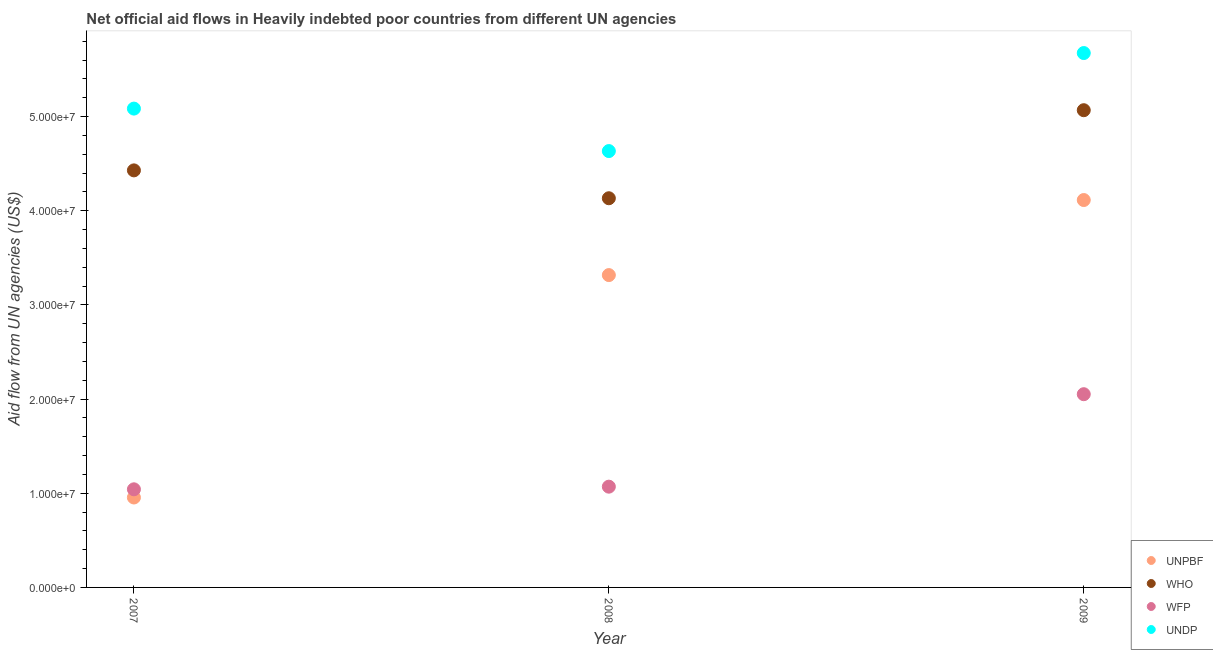What is the amount of aid given by undp in 2009?
Offer a very short reply. 5.68e+07. Across all years, what is the maximum amount of aid given by undp?
Provide a succinct answer. 5.68e+07. Across all years, what is the minimum amount of aid given by who?
Offer a very short reply. 4.13e+07. What is the total amount of aid given by who in the graph?
Provide a short and direct response. 1.36e+08. What is the difference between the amount of aid given by who in 2007 and that in 2008?
Your response must be concise. 2.96e+06. What is the difference between the amount of aid given by who in 2008 and the amount of aid given by unpbf in 2009?
Your response must be concise. 1.90e+05. What is the average amount of aid given by wfp per year?
Your answer should be very brief. 1.39e+07. In the year 2007, what is the difference between the amount of aid given by undp and amount of aid given by wfp?
Your answer should be very brief. 4.04e+07. In how many years, is the amount of aid given by who greater than 28000000 US$?
Your response must be concise. 3. What is the ratio of the amount of aid given by wfp in 2008 to that in 2009?
Offer a terse response. 0.52. What is the difference between the highest and the second highest amount of aid given by unpbf?
Provide a succinct answer. 7.97e+06. What is the difference between the highest and the lowest amount of aid given by unpbf?
Your answer should be very brief. 3.16e+07. Is the sum of the amount of aid given by who in 2007 and 2008 greater than the maximum amount of aid given by unpbf across all years?
Ensure brevity in your answer.  Yes. Does the amount of aid given by who monotonically increase over the years?
Keep it short and to the point. No. How many years are there in the graph?
Offer a terse response. 3. What is the difference between two consecutive major ticks on the Y-axis?
Your answer should be compact. 1.00e+07. Does the graph contain grids?
Ensure brevity in your answer.  No. How many legend labels are there?
Provide a succinct answer. 4. How are the legend labels stacked?
Make the answer very short. Vertical. What is the title of the graph?
Your answer should be very brief. Net official aid flows in Heavily indebted poor countries from different UN agencies. What is the label or title of the X-axis?
Offer a terse response. Year. What is the label or title of the Y-axis?
Your response must be concise. Aid flow from UN agencies (US$). What is the Aid flow from UN agencies (US$) in UNPBF in 2007?
Provide a short and direct response. 9.55e+06. What is the Aid flow from UN agencies (US$) of WHO in 2007?
Your response must be concise. 4.43e+07. What is the Aid flow from UN agencies (US$) of WFP in 2007?
Make the answer very short. 1.04e+07. What is the Aid flow from UN agencies (US$) of UNDP in 2007?
Your answer should be compact. 5.08e+07. What is the Aid flow from UN agencies (US$) of UNPBF in 2008?
Ensure brevity in your answer.  3.32e+07. What is the Aid flow from UN agencies (US$) in WHO in 2008?
Your response must be concise. 4.13e+07. What is the Aid flow from UN agencies (US$) in WFP in 2008?
Keep it short and to the point. 1.07e+07. What is the Aid flow from UN agencies (US$) in UNDP in 2008?
Provide a succinct answer. 4.63e+07. What is the Aid flow from UN agencies (US$) in UNPBF in 2009?
Your response must be concise. 4.11e+07. What is the Aid flow from UN agencies (US$) in WHO in 2009?
Ensure brevity in your answer.  5.07e+07. What is the Aid flow from UN agencies (US$) of WFP in 2009?
Provide a short and direct response. 2.05e+07. What is the Aid flow from UN agencies (US$) of UNDP in 2009?
Provide a succinct answer. 5.68e+07. Across all years, what is the maximum Aid flow from UN agencies (US$) in UNPBF?
Your response must be concise. 4.11e+07. Across all years, what is the maximum Aid flow from UN agencies (US$) in WHO?
Keep it short and to the point. 5.07e+07. Across all years, what is the maximum Aid flow from UN agencies (US$) in WFP?
Give a very brief answer. 2.05e+07. Across all years, what is the maximum Aid flow from UN agencies (US$) of UNDP?
Ensure brevity in your answer.  5.68e+07. Across all years, what is the minimum Aid flow from UN agencies (US$) of UNPBF?
Ensure brevity in your answer.  9.55e+06. Across all years, what is the minimum Aid flow from UN agencies (US$) of WHO?
Your answer should be compact. 4.13e+07. Across all years, what is the minimum Aid flow from UN agencies (US$) of WFP?
Your answer should be compact. 1.04e+07. Across all years, what is the minimum Aid flow from UN agencies (US$) of UNDP?
Keep it short and to the point. 4.63e+07. What is the total Aid flow from UN agencies (US$) in UNPBF in the graph?
Your answer should be very brief. 8.39e+07. What is the total Aid flow from UN agencies (US$) of WHO in the graph?
Make the answer very short. 1.36e+08. What is the total Aid flow from UN agencies (US$) in WFP in the graph?
Make the answer very short. 4.16e+07. What is the total Aid flow from UN agencies (US$) in UNDP in the graph?
Ensure brevity in your answer.  1.54e+08. What is the difference between the Aid flow from UN agencies (US$) of UNPBF in 2007 and that in 2008?
Offer a terse response. -2.36e+07. What is the difference between the Aid flow from UN agencies (US$) of WHO in 2007 and that in 2008?
Provide a succinct answer. 2.96e+06. What is the difference between the Aid flow from UN agencies (US$) in WFP in 2007 and that in 2008?
Keep it short and to the point. -2.80e+05. What is the difference between the Aid flow from UN agencies (US$) of UNDP in 2007 and that in 2008?
Your answer should be very brief. 4.51e+06. What is the difference between the Aid flow from UN agencies (US$) in UNPBF in 2007 and that in 2009?
Offer a terse response. -3.16e+07. What is the difference between the Aid flow from UN agencies (US$) in WHO in 2007 and that in 2009?
Ensure brevity in your answer.  -6.39e+06. What is the difference between the Aid flow from UN agencies (US$) in WFP in 2007 and that in 2009?
Provide a short and direct response. -1.01e+07. What is the difference between the Aid flow from UN agencies (US$) in UNDP in 2007 and that in 2009?
Ensure brevity in your answer.  -5.90e+06. What is the difference between the Aid flow from UN agencies (US$) in UNPBF in 2008 and that in 2009?
Make the answer very short. -7.97e+06. What is the difference between the Aid flow from UN agencies (US$) in WHO in 2008 and that in 2009?
Ensure brevity in your answer.  -9.35e+06. What is the difference between the Aid flow from UN agencies (US$) in WFP in 2008 and that in 2009?
Keep it short and to the point. -9.82e+06. What is the difference between the Aid flow from UN agencies (US$) in UNDP in 2008 and that in 2009?
Your answer should be compact. -1.04e+07. What is the difference between the Aid flow from UN agencies (US$) in UNPBF in 2007 and the Aid flow from UN agencies (US$) in WHO in 2008?
Offer a terse response. -3.18e+07. What is the difference between the Aid flow from UN agencies (US$) in UNPBF in 2007 and the Aid flow from UN agencies (US$) in WFP in 2008?
Give a very brief answer. -1.15e+06. What is the difference between the Aid flow from UN agencies (US$) of UNPBF in 2007 and the Aid flow from UN agencies (US$) of UNDP in 2008?
Offer a terse response. -3.68e+07. What is the difference between the Aid flow from UN agencies (US$) in WHO in 2007 and the Aid flow from UN agencies (US$) in WFP in 2008?
Provide a succinct answer. 3.36e+07. What is the difference between the Aid flow from UN agencies (US$) in WHO in 2007 and the Aid flow from UN agencies (US$) in UNDP in 2008?
Keep it short and to the point. -2.05e+06. What is the difference between the Aid flow from UN agencies (US$) of WFP in 2007 and the Aid flow from UN agencies (US$) of UNDP in 2008?
Make the answer very short. -3.59e+07. What is the difference between the Aid flow from UN agencies (US$) of UNPBF in 2007 and the Aid flow from UN agencies (US$) of WHO in 2009?
Give a very brief answer. -4.11e+07. What is the difference between the Aid flow from UN agencies (US$) in UNPBF in 2007 and the Aid flow from UN agencies (US$) in WFP in 2009?
Offer a very short reply. -1.10e+07. What is the difference between the Aid flow from UN agencies (US$) in UNPBF in 2007 and the Aid flow from UN agencies (US$) in UNDP in 2009?
Make the answer very short. -4.72e+07. What is the difference between the Aid flow from UN agencies (US$) of WHO in 2007 and the Aid flow from UN agencies (US$) of WFP in 2009?
Your answer should be very brief. 2.38e+07. What is the difference between the Aid flow from UN agencies (US$) of WHO in 2007 and the Aid flow from UN agencies (US$) of UNDP in 2009?
Your answer should be compact. -1.25e+07. What is the difference between the Aid flow from UN agencies (US$) of WFP in 2007 and the Aid flow from UN agencies (US$) of UNDP in 2009?
Your answer should be compact. -4.63e+07. What is the difference between the Aid flow from UN agencies (US$) in UNPBF in 2008 and the Aid flow from UN agencies (US$) in WHO in 2009?
Ensure brevity in your answer.  -1.75e+07. What is the difference between the Aid flow from UN agencies (US$) in UNPBF in 2008 and the Aid flow from UN agencies (US$) in WFP in 2009?
Your answer should be compact. 1.26e+07. What is the difference between the Aid flow from UN agencies (US$) of UNPBF in 2008 and the Aid flow from UN agencies (US$) of UNDP in 2009?
Ensure brevity in your answer.  -2.36e+07. What is the difference between the Aid flow from UN agencies (US$) in WHO in 2008 and the Aid flow from UN agencies (US$) in WFP in 2009?
Provide a short and direct response. 2.08e+07. What is the difference between the Aid flow from UN agencies (US$) in WHO in 2008 and the Aid flow from UN agencies (US$) in UNDP in 2009?
Give a very brief answer. -1.54e+07. What is the difference between the Aid flow from UN agencies (US$) in WFP in 2008 and the Aid flow from UN agencies (US$) in UNDP in 2009?
Give a very brief answer. -4.60e+07. What is the average Aid flow from UN agencies (US$) in UNPBF per year?
Keep it short and to the point. 2.80e+07. What is the average Aid flow from UN agencies (US$) in WHO per year?
Your answer should be compact. 4.54e+07. What is the average Aid flow from UN agencies (US$) of WFP per year?
Your answer should be very brief. 1.39e+07. What is the average Aid flow from UN agencies (US$) of UNDP per year?
Provide a short and direct response. 5.13e+07. In the year 2007, what is the difference between the Aid flow from UN agencies (US$) of UNPBF and Aid flow from UN agencies (US$) of WHO?
Offer a terse response. -3.47e+07. In the year 2007, what is the difference between the Aid flow from UN agencies (US$) in UNPBF and Aid flow from UN agencies (US$) in WFP?
Your answer should be compact. -8.70e+05. In the year 2007, what is the difference between the Aid flow from UN agencies (US$) in UNPBF and Aid flow from UN agencies (US$) in UNDP?
Your response must be concise. -4.13e+07. In the year 2007, what is the difference between the Aid flow from UN agencies (US$) in WHO and Aid flow from UN agencies (US$) in WFP?
Your response must be concise. 3.39e+07. In the year 2007, what is the difference between the Aid flow from UN agencies (US$) in WHO and Aid flow from UN agencies (US$) in UNDP?
Offer a terse response. -6.56e+06. In the year 2007, what is the difference between the Aid flow from UN agencies (US$) in WFP and Aid flow from UN agencies (US$) in UNDP?
Your answer should be compact. -4.04e+07. In the year 2008, what is the difference between the Aid flow from UN agencies (US$) of UNPBF and Aid flow from UN agencies (US$) of WHO?
Make the answer very short. -8.16e+06. In the year 2008, what is the difference between the Aid flow from UN agencies (US$) of UNPBF and Aid flow from UN agencies (US$) of WFP?
Make the answer very short. 2.25e+07. In the year 2008, what is the difference between the Aid flow from UN agencies (US$) in UNPBF and Aid flow from UN agencies (US$) in UNDP?
Provide a succinct answer. -1.32e+07. In the year 2008, what is the difference between the Aid flow from UN agencies (US$) in WHO and Aid flow from UN agencies (US$) in WFP?
Provide a succinct answer. 3.06e+07. In the year 2008, what is the difference between the Aid flow from UN agencies (US$) in WHO and Aid flow from UN agencies (US$) in UNDP?
Your response must be concise. -5.01e+06. In the year 2008, what is the difference between the Aid flow from UN agencies (US$) in WFP and Aid flow from UN agencies (US$) in UNDP?
Offer a terse response. -3.56e+07. In the year 2009, what is the difference between the Aid flow from UN agencies (US$) of UNPBF and Aid flow from UN agencies (US$) of WHO?
Provide a succinct answer. -9.54e+06. In the year 2009, what is the difference between the Aid flow from UN agencies (US$) of UNPBF and Aid flow from UN agencies (US$) of WFP?
Provide a succinct answer. 2.06e+07. In the year 2009, what is the difference between the Aid flow from UN agencies (US$) in UNPBF and Aid flow from UN agencies (US$) in UNDP?
Keep it short and to the point. -1.56e+07. In the year 2009, what is the difference between the Aid flow from UN agencies (US$) in WHO and Aid flow from UN agencies (US$) in WFP?
Ensure brevity in your answer.  3.02e+07. In the year 2009, what is the difference between the Aid flow from UN agencies (US$) of WHO and Aid flow from UN agencies (US$) of UNDP?
Keep it short and to the point. -6.07e+06. In the year 2009, what is the difference between the Aid flow from UN agencies (US$) of WFP and Aid flow from UN agencies (US$) of UNDP?
Ensure brevity in your answer.  -3.62e+07. What is the ratio of the Aid flow from UN agencies (US$) in UNPBF in 2007 to that in 2008?
Your answer should be compact. 0.29. What is the ratio of the Aid flow from UN agencies (US$) in WHO in 2007 to that in 2008?
Your response must be concise. 1.07. What is the ratio of the Aid flow from UN agencies (US$) in WFP in 2007 to that in 2008?
Ensure brevity in your answer.  0.97. What is the ratio of the Aid flow from UN agencies (US$) in UNDP in 2007 to that in 2008?
Give a very brief answer. 1.1. What is the ratio of the Aid flow from UN agencies (US$) in UNPBF in 2007 to that in 2009?
Provide a succinct answer. 0.23. What is the ratio of the Aid flow from UN agencies (US$) of WHO in 2007 to that in 2009?
Make the answer very short. 0.87. What is the ratio of the Aid flow from UN agencies (US$) in WFP in 2007 to that in 2009?
Offer a terse response. 0.51. What is the ratio of the Aid flow from UN agencies (US$) of UNDP in 2007 to that in 2009?
Ensure brevity in your answer.  0.9. What is the ratio of the Aid flow from UN agencies (US$) of UNPBF in 2008 to that in 2009?
Your answer should be very brief. 0.81. What is the ratio of the Aid flow from UN agencies (US$) of WHO in 2008 to that in 2009?
Give a very brief answer. 0.82. What is the ratio of the Aid flow from UN agencies (US$) of WFP in 2008 to that in 2009?
Give a very brief answer. 0.52. What is the ratio of the Aid flow from UN agencies (US$) in UNDP in 2008 to that in 2009?
Provide a short and direct response. 0.82. What is the difference between the highest and the second highest Aid flow from UN agencies (US$) in UNPBF?
Keep it short and to the point. 7.97e+06. What is the difference between the highest and the second highest Aid flow from UN agencies (US$) in WHO?
Your answer should be very brief. 6.39e+06. What is the difference between the highest and the second highest Aid flow from UN agencies (US$) of WFP?
Keep it short and to the point. 9.82e+06. What is the difference between the highest and the second highest Aid flow from UN agencies (US$) in UNDP?
Ensure brevity in your answer.  5.90e+06. What is the difference between the highest and the lowest Aid flow from UN agencies (US$) of UNPBF?
Offer a very short reply. 3.16e+07. What is the difference between the highest and the lowest Aid flow from UN agencies (US$) of WHO?
Provide a short and direct response. 9.35e+06. What is the difference between the highest and the lowest Aid flow from UN agencies (US$) of WFP?
Offer a terse response. 1.01e+07. What is the difference between the highest and the lowest Aid flow from UN agencies (US$) of UNDP?
Make the answer very short. 1.04e+07. 